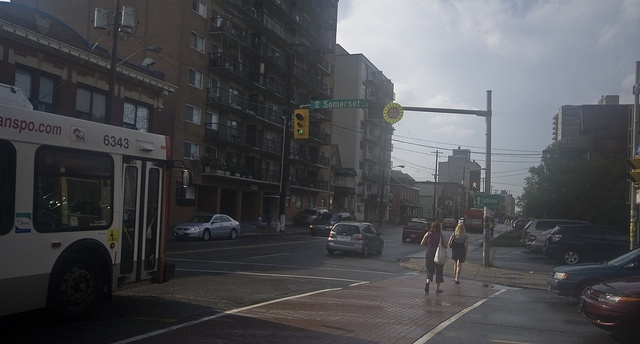Describe the objects in this image and their specific colors. I can see bus in lightgray, black, gray, and darkgreen tones, car in lightgray, black, gray, and darkgreen tones, car in lightgray, black, and gray tones, car in lightgray, black, and gray tones, and car in lightgray, black, and gray tones in this image. 